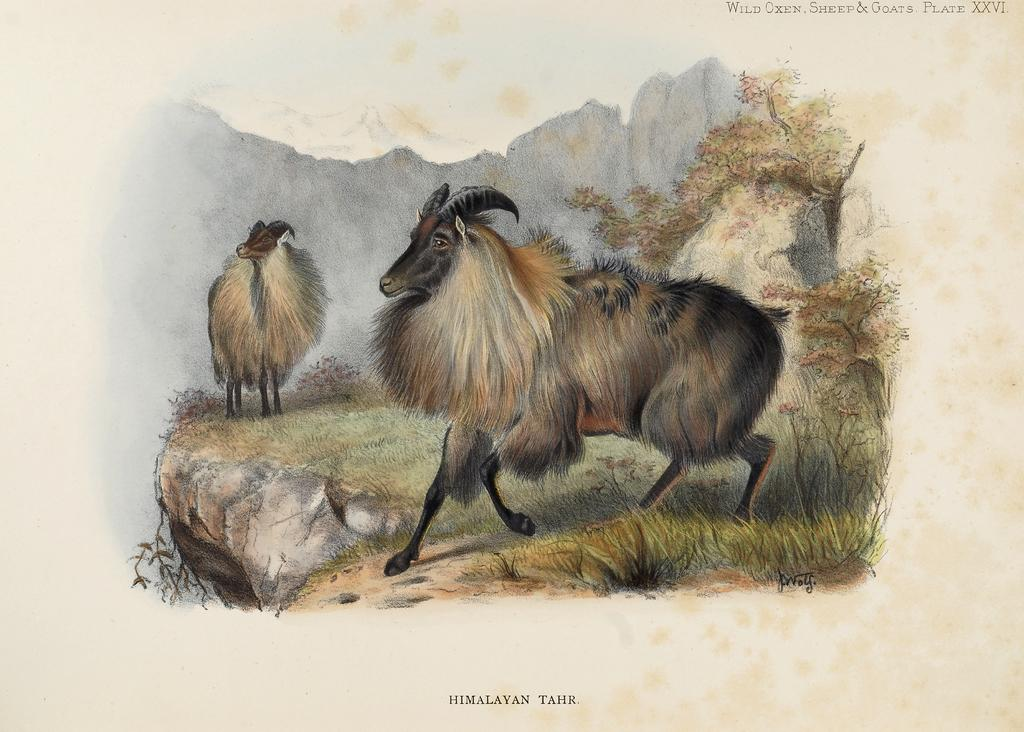What is depicted in the picture in the image? There is a picture of animals in the image. What type of natural environment is visible in the image? There is grass, a mountain, and trees visible in the image. Is there any text present in the image? Yes, there is text at the bottom of the image. What type of iron is being used by the animals in the image? There is no iron present in the image, as it features a picture of animals in a natural environment. What type of lettuce can be seen growing near the mountain in the image? There is no lettuce visible in the image; it only shows animals, grass, a mountain, trees, and text. 